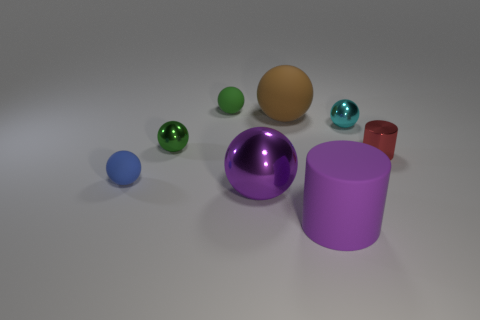What color is the tiny ball that is behind the shiny ball that is on the right side of the brown ball?
Offer a terse response. Green. What number of small objects are rubber cylinders or metallic spheres?
Provide a succinct answer. 2. What color is the metallic sphere that is both right of the green rubber thing and behind the small red cylinder?
Make the answer very short. Cyan. Do the brown object and the small blue sphere have the same material?
Your response must be concise. Yes. There is a tiny red metallic thing; what shape is it?
Provide a succinct answer. Cylinder. What number of large balls are in front of the metallic ball that is behind the green object that is in front of the tiny cyan sphere?
Give a very brief answer. 1. The other tiny metal thing that is the same shape as the green metallic object is what color?
Keep it short and to the point. Cyan. What shape is the big purple object to the left of the cylinder that is left of the tiny sphere right of the large purple rubber cylinder?
Provide a succinct answer. Sphere. There is a rubber thing that is both in front of the tiny green metal thing and behind the rubber cylinder; what size is it?
Ensure brevity in your answer.  Small. Are there fewer big yellow objects than brown matte spheres?
Make the answer very short. Yes. 